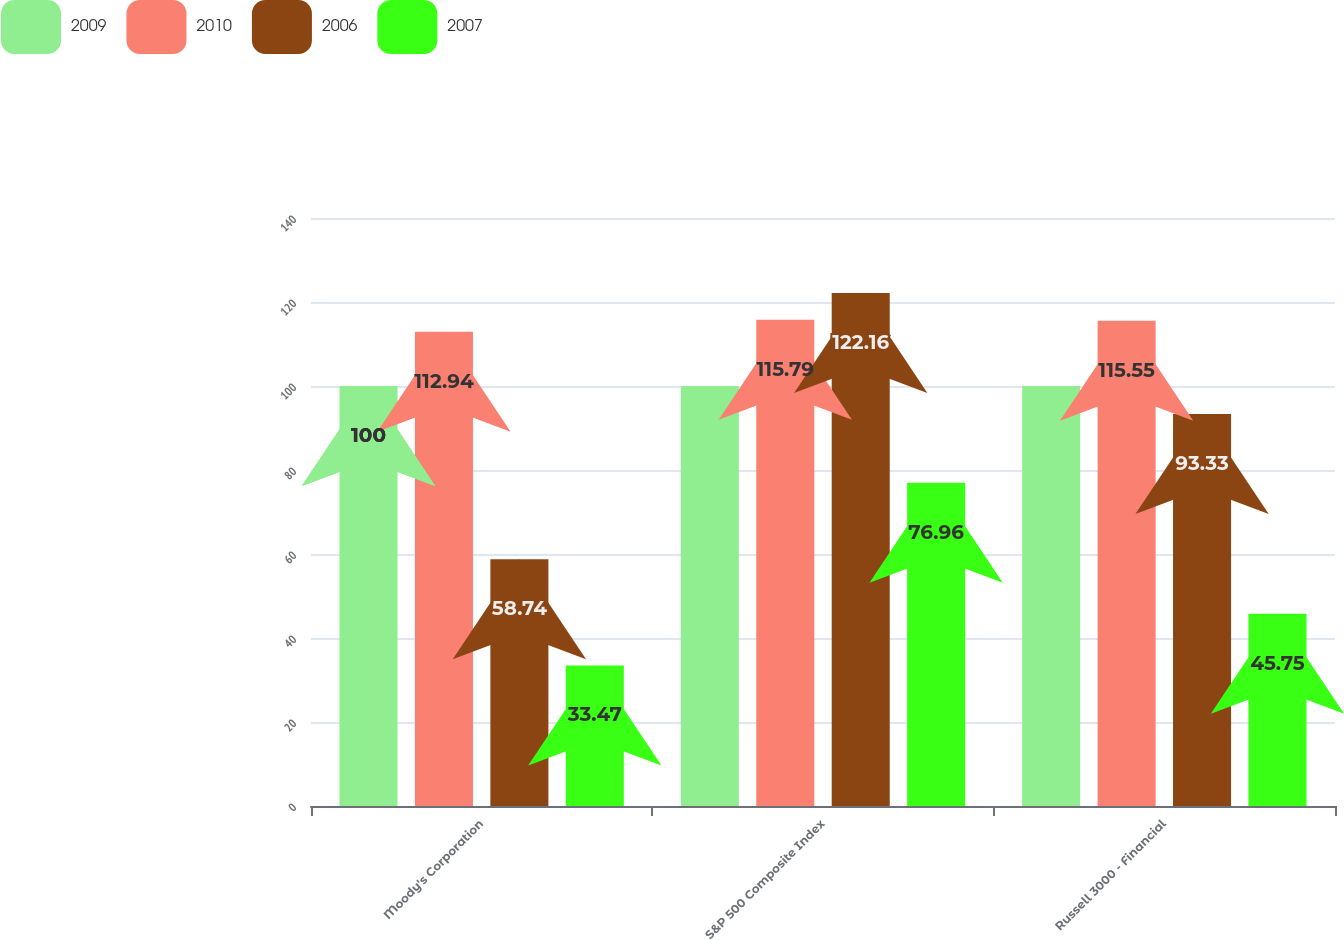Convert chart. <chart><loc_0><loc_0><loc_500><loc_500><stacked_bar_chart><ecel><fcel>Moody's Corporation<fcel>S&P 500 Composite Index<fcel>Russell 3000 - Financial<nl><fcel>2009<fcel>100<fcel>100<fcel>100<nl><fcel>2010<fcel>112.94<fcel>115.79<fcel>115.55<nl><fcel>2006<fcel>58.74<fcel>122.16<fcel>93.33<nl><fcel>2007<fcel>33.47<fcel>76.96<fcel>45.75<nl></chart> 